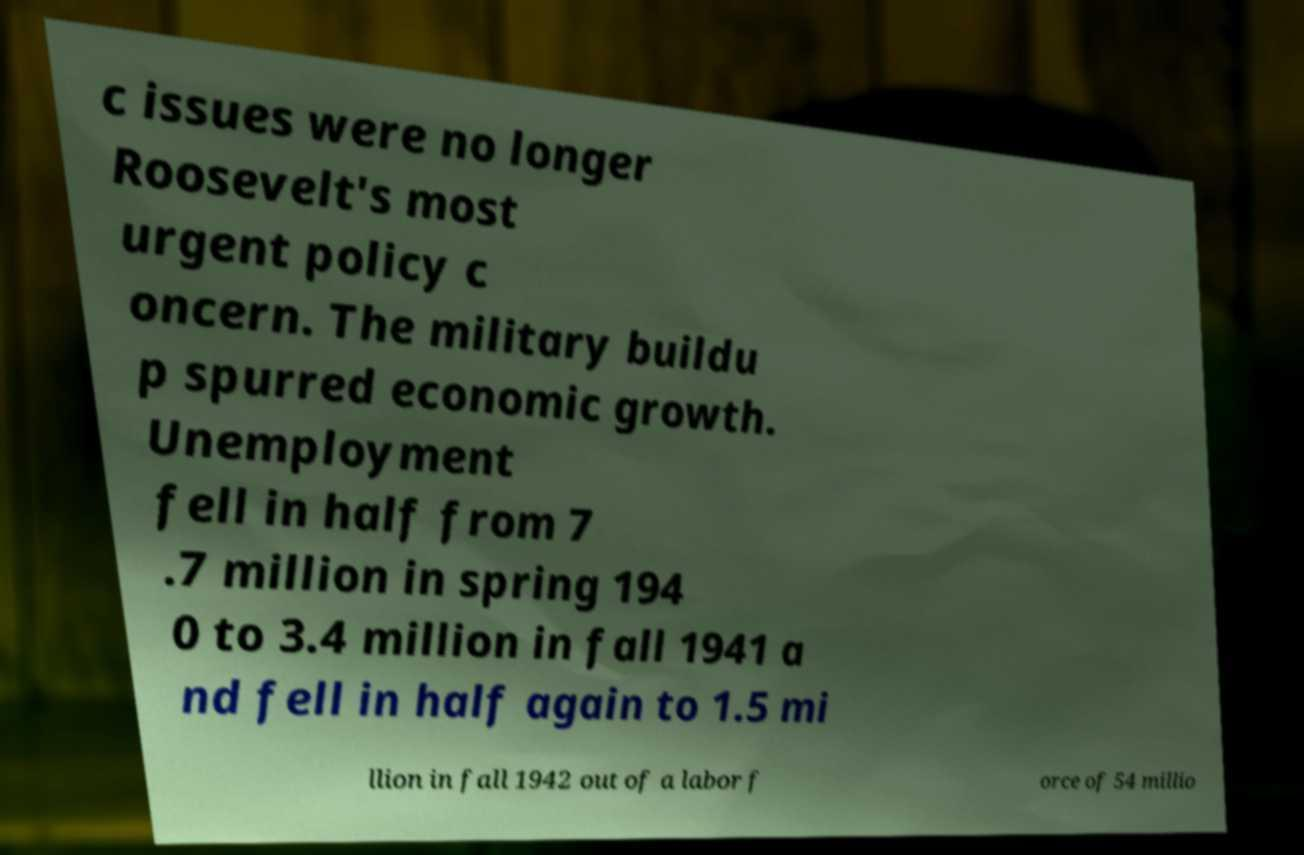For documentation purposes, I need the text within this image transcribed. Could you provide that? c issues were no longer Roosevelt's most urgent policy c oncern. The military buildu p spurred economic growth. Unemployment fell in half from 7 .7 million in spring 194 0 to 3.4 million in fall 1941 a nd fell in half again to 1.5 mi llion in fall 1942 out of a labor f orce of 54 millio 